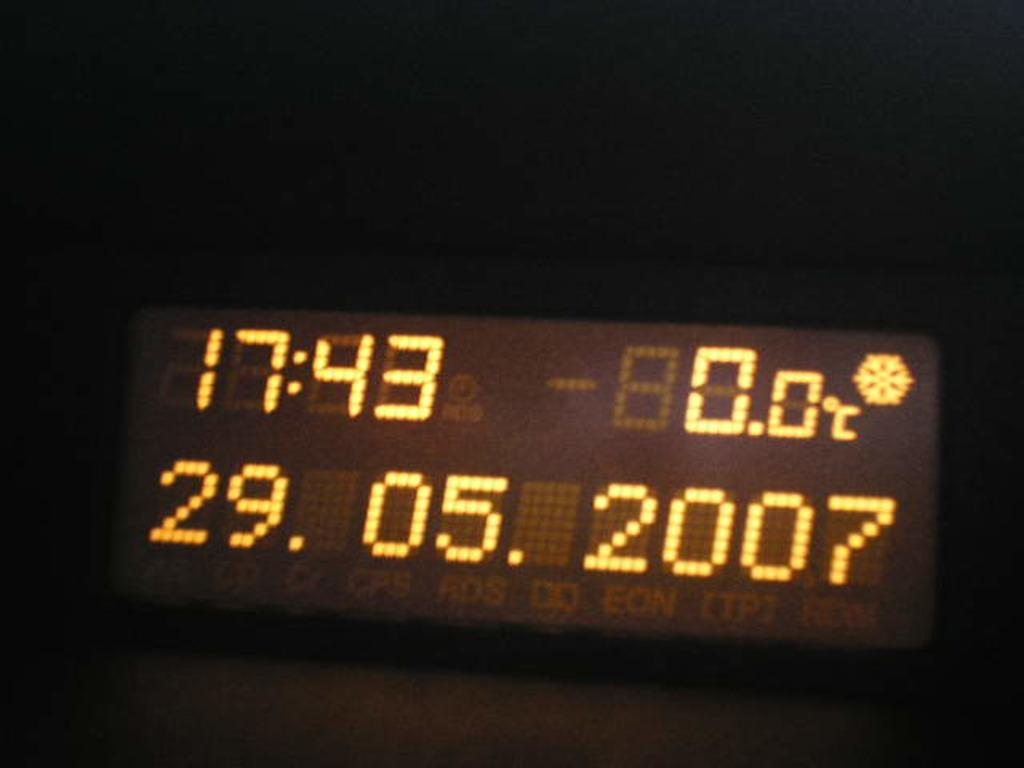Provide a one-sentence caption for the provided image. A display with the time at 17:43 on May 29th 2007. 